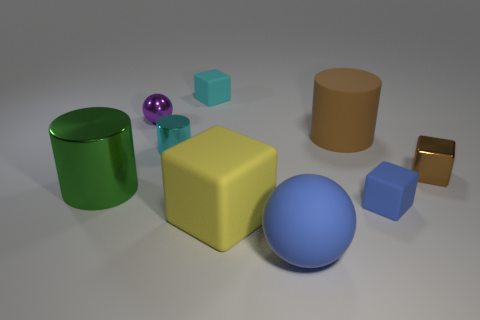What time of day does the lighting suggest in this scene? The lighting in the scene doesn't align with a specific time of day, as this appears to be a controlled environment with an artificial and neutral light source that casts soft shadows. This type of lighting is typical in studio settings. 